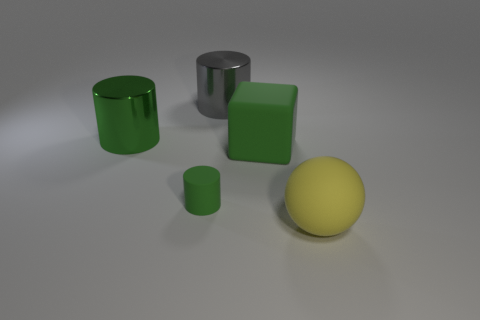What is the shape of the green thing that is to the right of the large shiny cylinder that is on the right side of the small cylinder?
Offer a very short reply. Cube. Is the number of large rubber objects that are in front of the tiny rubber object less than the number of things that are on the left side of the yellow object?
Offer a very short reply. Yes. What is the size of the other metal thing that is the same shape as the large gray shiny thing?
Offer a terse response. Large. Are there any other things that are the same size as the rubber cylinder?
Keep it short and to the point. No. What number of things are either yellow things that are in front of the green cube or green things behind the small green matte cylinder?
Your answer should be very brief. 3. Is the green cube the same size as the gray shiny cylinder?
Give a very brief answer. Yes. Is the number of green rubber cylinders greater than the number of green matte objects?
Provide a short and direct response. No. What number of other objects are there of the same color as the small matte cylinder?
Keep it short and to the point. 2. What number of things are either tiny purple spheres or large green shiny cylinders?
Offer a terse response. 1. There is a thing behind the green shiny thing; does it have the same shape as the large green shiny thing?
Offer a very short reply. Yes. 